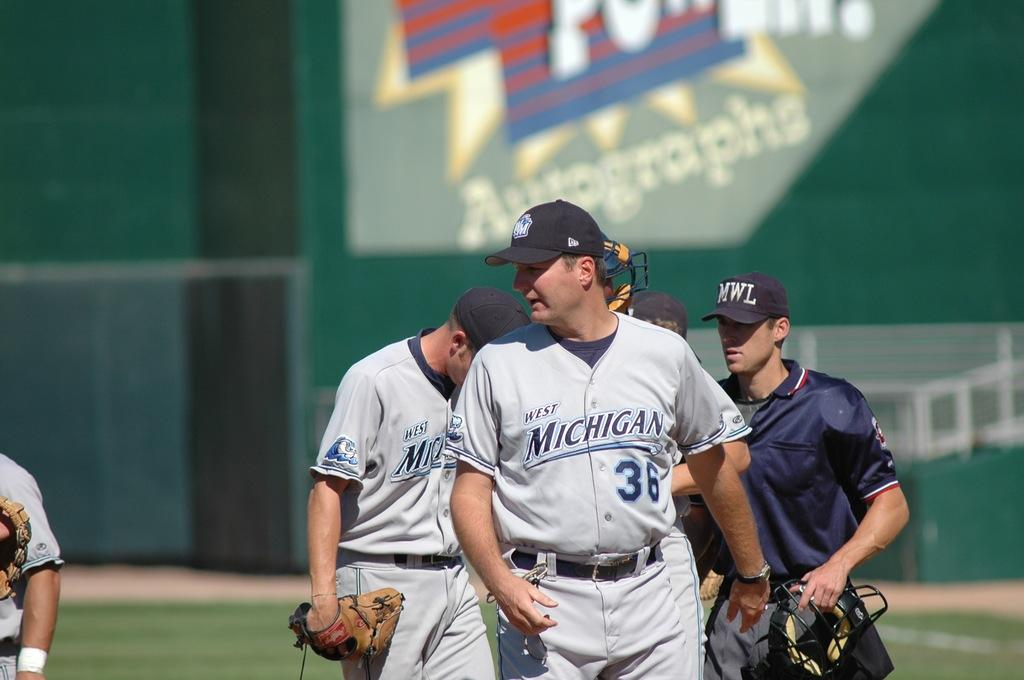<image>
Offer a succinct explanation of the picture presented. number 36 of the Michigan team is walking in the front 